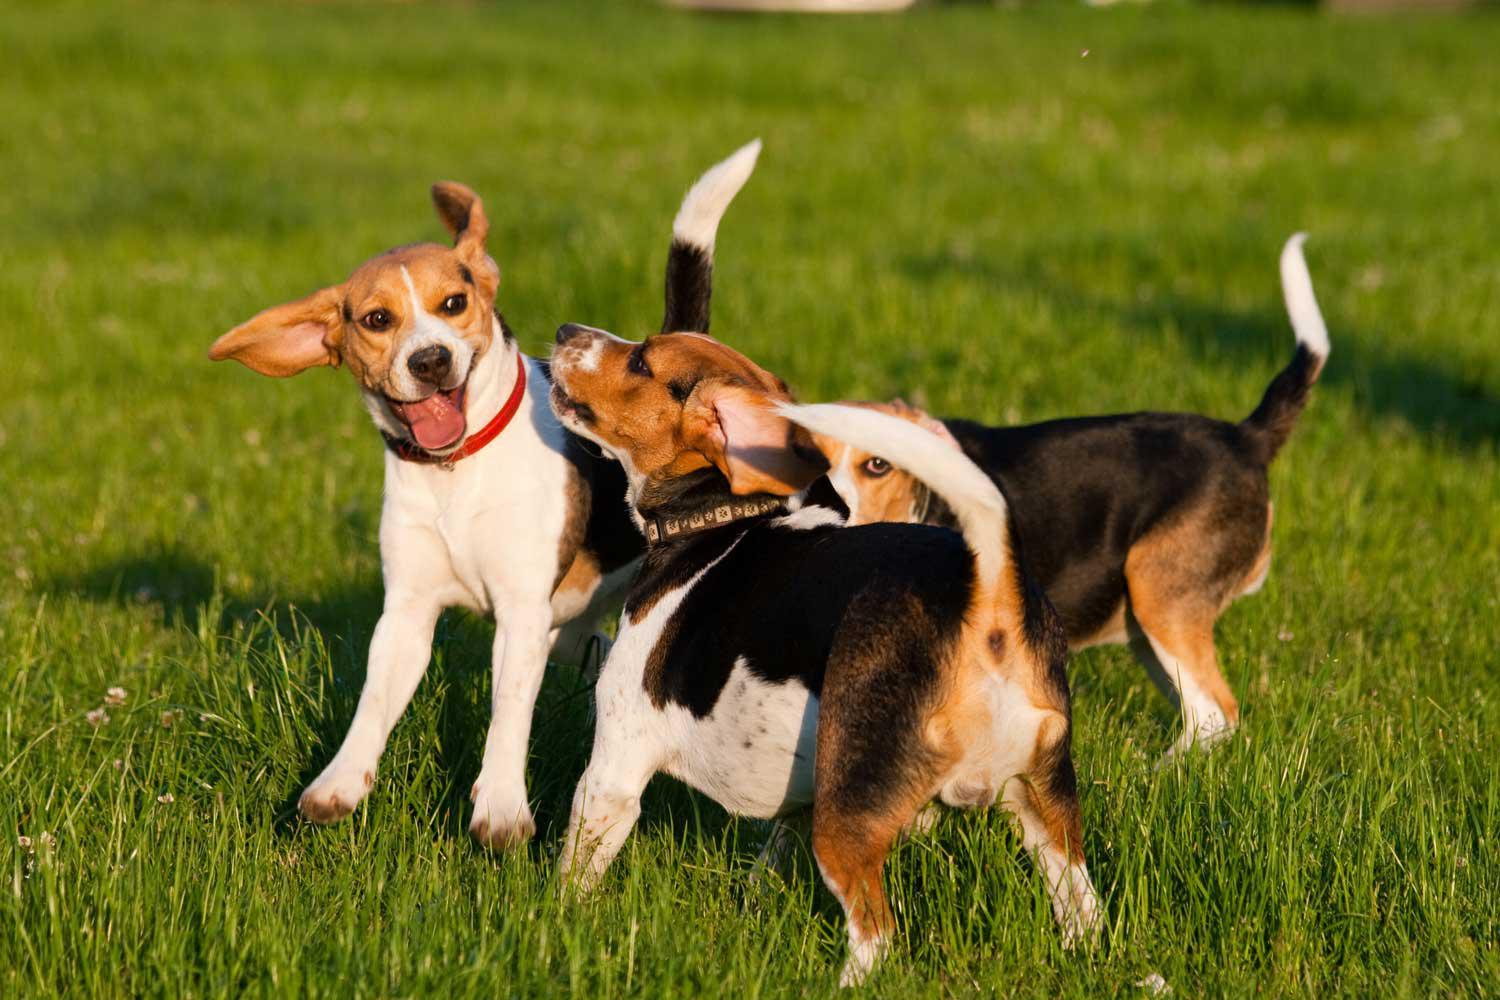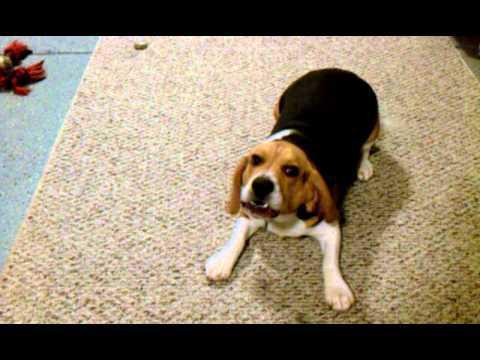The first image is the image on the left, the second image is the image on the right. For the images displayed, is the sentence "There are more dogs in the image on the right than on the left." factually correct? Answer yes or no. No. The first image is the image on the left, the second image is the image on the right. Examine the images to the left and right. Is the description "The right image contains at least two dogs." accurate? Answer yes or no. No. 